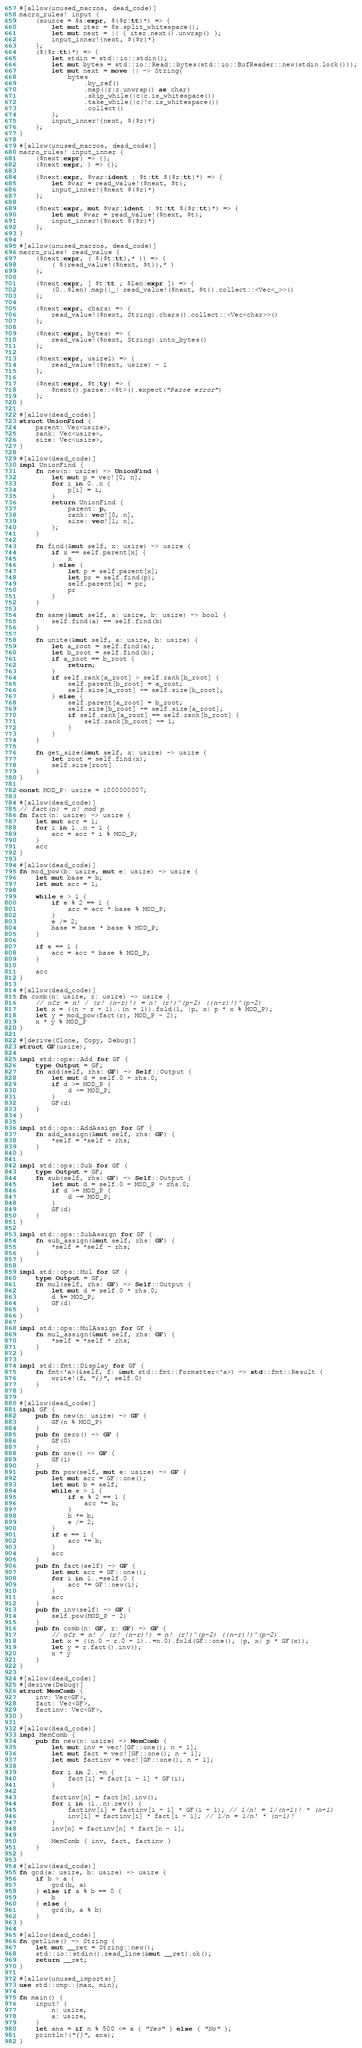Convert code to text. <code><loc_0><loc_0><loc_500><loc_500><_Rust_>#[allow(unused_macros, dead_code)]
macro_rules! input {
    (source = $s:expr, $($r:tt)*) => {
        let mut iter = $s.split_whitespace();
        let mut next = || { iter.next().unwrap() };
        input_inner!{next, $($r)*}
    };
    ($($r:tt)*) => {
        let stdin = std::io::stdin();
        let mut bytes = std::io::Read::bytes(std::io::BufReader::new(stdin.lock()));
        let mut next = move || -> String{
            bytes
                .by_ref()
                .map(|r|r.unwrap() as char)
                .skip_while(|c|c.is_whitespace())
                .take_while(|c|!c.is_whitespace())
                .collect()
        };
        input_inner!{next, $($r)*}
    };
}

#[allow(unused_macros, dead_code)]
macro_rules! input_inner {
    ($next:expr) => {};
    ($next:expr, ) => {};

    ($next:expr, $var:ident : $t:tt $($r:tt)*) => {
        let $var = read_value!($next, $t);
        input_inner!{$next $($r)*}
    };

    ($next:expr, mut $var:ident : $t:tt $($r:tt)*) => {
        let mut $var = read_value!($next, $t);
        input_inner!{$next $($r)*}
    };
}

#[allow(unused_macros, dead_code)]
macro_rules! read_value {
    ($next:expr, ( $($t:tt),* )) => {
        ( $(read_value!($next, $t)),* )
    };

    ($next:expr, [ $t:tt ; $len:expr ]) => {
        (0..$len).map(|_| read_value!($next, $t)).collect::<Vec<_>>()
    };

    ($next:expr, chars) => {
        read_value!($next, String).chars().collect::<Vec<char>>()
    };

    ($next:expr, bytes) => {
        read_value!($next, String).into_bytes()
    };

    ($next:expr, usize1) => {
        read_value!($next, usize) - 1
    };

    ($next:expr, $t:ty) => {
        $next().parse::<$t>().expect("Parse error")
    };
}

#[allow(dead_code)]
struct UnionFind {
    parent: Vec<usize>,
    rank: Vec<usize>,
    size: Vec<usize>,
}

#[allow(dead_code)]
impl UnionFind {
    fn new(n: usize) -> UnionFind {
        let mut p = vec![0; n];
        for i in 0..n {
            p[i] = i;
        }
        return UnionFind {
            parent: p,
            rank: vec![0; n],
            size: vec![1; n],
        };
    }

    fn find(&mut self, x: usize) -> usize {
        if x == self.parent[x] {
            x
        } else {
            let p = self.parent[x];
            let pr = self.find(p);
            self.parent[x] = pr;
            pr
        }
    }

    fn same(&mut self, a: usize, b: usize) -> bool {
        self.find(a) == self.find(b)
    }

    fn unite(&mut self, a: usize, b: usize) {
        let a_root = self.find(a);
        let b_root = self.find(b);
        if a_root == b_root {
            return;
        }
        if self.rank[a_root] > self.rank[b_root] {
            self.parent[b_root] = a_root;
            self.size[a_root] += self.size[b_root];
        } else {
            self.parent[a_root] = b_root;
            self.size[b_root] += self.size[a_root];
            if self.rank[a_root] == self.rank[b_root] {
                self.rank[b_root] += 1;
            }
        }
    }

    fn get_size(&mut self, x: usize) -> usize {
        let root = self.find(x);
        self.size[root]
    }
}

const MOD_P: usize = 1000000007;

#[allow(dead_code)]
// fact(n) = n! mod p
fn fact(n: usize) -> usize {
    let mut acc = 1;
    for i in 1..n + 1 {
        acc = acc * i % MOD_P;
    }
    acc
}

#[allow(dead_code)]
fn mod_pow(b: usize, mut e: usize) -> usize {
    let mut base = b;
    let mut acc = 1;

    while e > 1 {
        if e % 2 == 1 {
            acc = acc * base % MOD_P;
        }
        e /= 2;
        base = base * base % MOD_P;
    }

    if e == 1 {
        acc = acc * base % MOD_P;
    }

    acc
}

#[allow(dead_code)]
fn comb(n: usize, r: usize) -> usize {
    // nCr = n! / (r! (n-r)!) = n! (r!)^(p-2) ((n-r)!)^(p-2)
    let x = ((n - r + 1)..(n + 1)).fold(1, |p, x| p * x % MOD_P);
    let y = mod_pow(fact(r), MOD_P - 2);
    x * y % MOD_P
}

#[derive(Clone, Copy, Debug)]
struct GF(usize);

impl std::ops::Add for GF {
    type Output = GF;
    fn add(self, rhs: GF) -> Self::Output {
        let mut d = self.0 + rhs.0;
        if d >= MOD_P {
            d -= MOD_P;
        }
        GF(d)
    }
}

impl std::ops::AddAssign for GF {
    fn add_assign(&mut self, rhs: GF) {
        *self = *self + rhs;
    }
}

impl std::ops::Sub for GF {
    type Output = GF;
    fn sub(self, rhs: GF) -> Self::Output {
        let mut d = self.0 + MOD_P - rhs.0;
        if d >= MOD_P {
            d -= MOD_P;
        }
        GF(d)
    }
}

impl std::ops::SubAssign for GF {
    fn sub_assign(&mut self, rhs: GF) {
        *self = *self - rhs;
    }
}

impl std::ops::Mul for GF {
    type Output = GF;
    fn mul(self, rhs: GF) -> Self::Output {
        let mut d = self.0 * rhs.0;
        d %= MOD_P;
        GF(d)
    }
}

impl std::ops::MulAssign for GF {
    fn mul_assign(&mut self, rhs: GF) {
        *self = *self * rhs;
    }
}

impl std::fmt::Display for GF {
    fn fmt<'a>(&self, f: &mut std::fmt::Formatter<'a>) -> std::fmt::Result {
        write!(f, "{}", self.0)
    }
}

#[allow(dead_code)]
impl GF {
    pub fn new(n: usize) -> GF {
        GF(n % MOD_P)
    }
    pub fn zero() -> GF {
        GF(0)
    }
    pub fn one() -> GF {
        GF(1)
    }
    pub fn pow(self, mut e: usize) -> GF {
        let mut acc = GF::one();
        let mut b = self;
        while e > 1 {
            if e % 2 == 1 {
                acc *= b;
            }
            b *= b;
            e /= 2;
        }
        if e == 1 {
            acc *= b;
        }
        acc
    }
    pub fn fact(self) -> GF {
        let mut acc = GF::one();
        for i in 1..=self.0 {
            acc *= GF::new(i);
        }
        acc
    }
    pub fn inv(self) -> GF {
        self.pow(MOD_P - 2)
    }
    pub fn comb(n: GF, r: GF) -> GF {
        // nCr = n! / (r! (n-r)!) = n! (r!)^(p-2) ((n-r)!)^(p-2)
        let x = ((n.0 - r.0 + 1)..=n.0).fold(GF::one(), |p, x| p * GF(x));
        let y = r.fact().inv();
        x * y
    }
}

#[allow(dead_code)]
#[derive(Debug)]
struct MemComb {
    inv: Vec<GF>,
    fact: Vec<GF>,
    factinv: Vec<GF>,
}

#[allow(dead_code)]
impl MemComb {
    pub fn new(n: usize) -> MemComb {
        let mut inv = vec![GF::one(); n + 1];
        let mut fact = vec![GF::one(); n + 1];
        let mut factinv = vec![GF::one(); n + 1];

        for i in 2..=n {
            fact[i] = fact[i - 1] * GF(i);
        }

        factinv[n] = fact[n].inv();
        for i in (1..n).rev() {
            factinv[i] = factinv[i + 1] * GF(i + 1); // 1/n! = 1/(n+1)! * (n+1)
            inv[i] = factinv[i] * fact[i - 1]; // 1/n = 1/n! * (n-1)!
        }
        inv[n] = factinv[n] * fact[n - 1];

        MemComb { inv, fact, factinv }
    }
}

#[allow(dead_code)]
fn gcd(a: usize, b: usize) -> usize {
    if b > a {
        gcd(b, a)
    } else if a % b == 0 {
        b
    } else {
        gcd(b, a % b)
    }
}

#[allow(dead_code)]
fn getline() -> String {
    let mut __ret = String::new();
    std::io::stdin().read_line(&mut __ret).ok();
    return __ret;
}

#[allow(unused_imports)]
use std::cmp::{max, min};

fn main() {
    input! {
        n: usize,
        a: usize,
    }
    let ans = if n % 500 <= a { "Yes" } else { "No" };
    println!("{}", ans);
}
</code> 